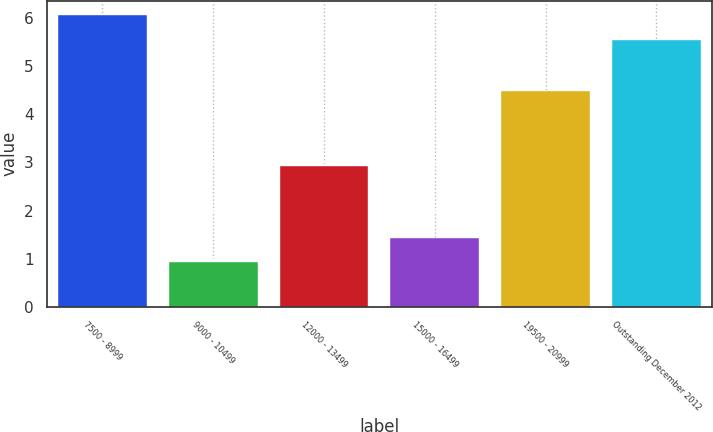<chart> <loc_0><loc_0><loc_500><loc_500><bar_chart><fcel>7500 - 8999<fcel>9000 - 10499<fcel>12000 - 13499<fcel>15000 - 16499<fcel>19500 - 20999<fcel>Outstanding December 2012<nl><fcel>6.06<fcel>0.92<fcel>2.92<fcel>1.43<fcel>4.48<fcel>5.55<nl></chart> 